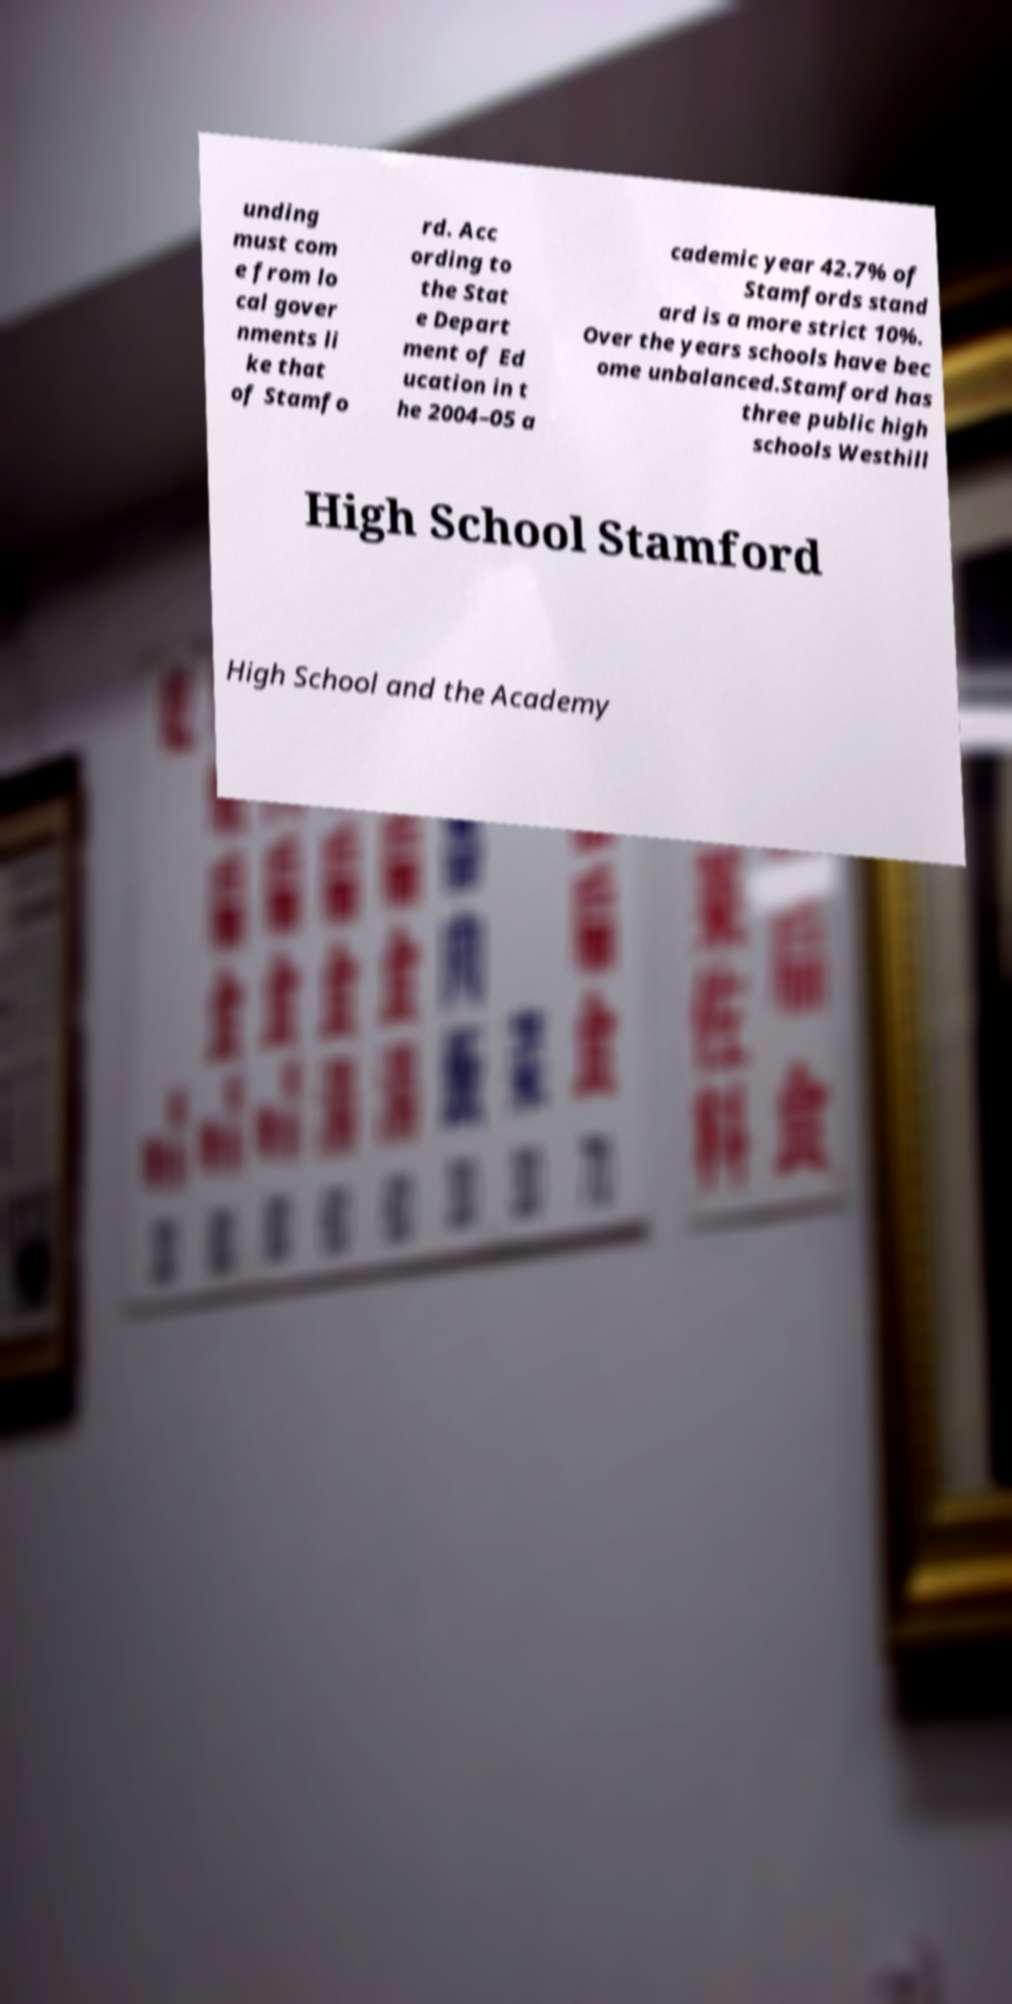Could you extract and type out the text from this image? unding must com e from lo cal gover nments li ke that of Stamfo rd. Acc ording to the Stat e Depart ment of Ed ucation in t he 2004–05 a cademic year 42.7% of Stamfords stand ard is a more strict 10%. Over the years schools have bec ome unbalanced.Stamford has three public high schools Westhill High School Stamford High School and the Academy 